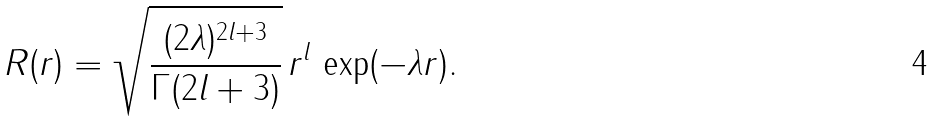<formula> <loc_0><loc_0><loc_500><loc_500>R ( r ) = \sqrt { \frac { ( 2 \lambda ) ^ { 2 l + 3 } } { \Gamma ( 2 l + 3 ) } } \, r ^ { l } \, \exp ( - \lambda r ) .</formula> 